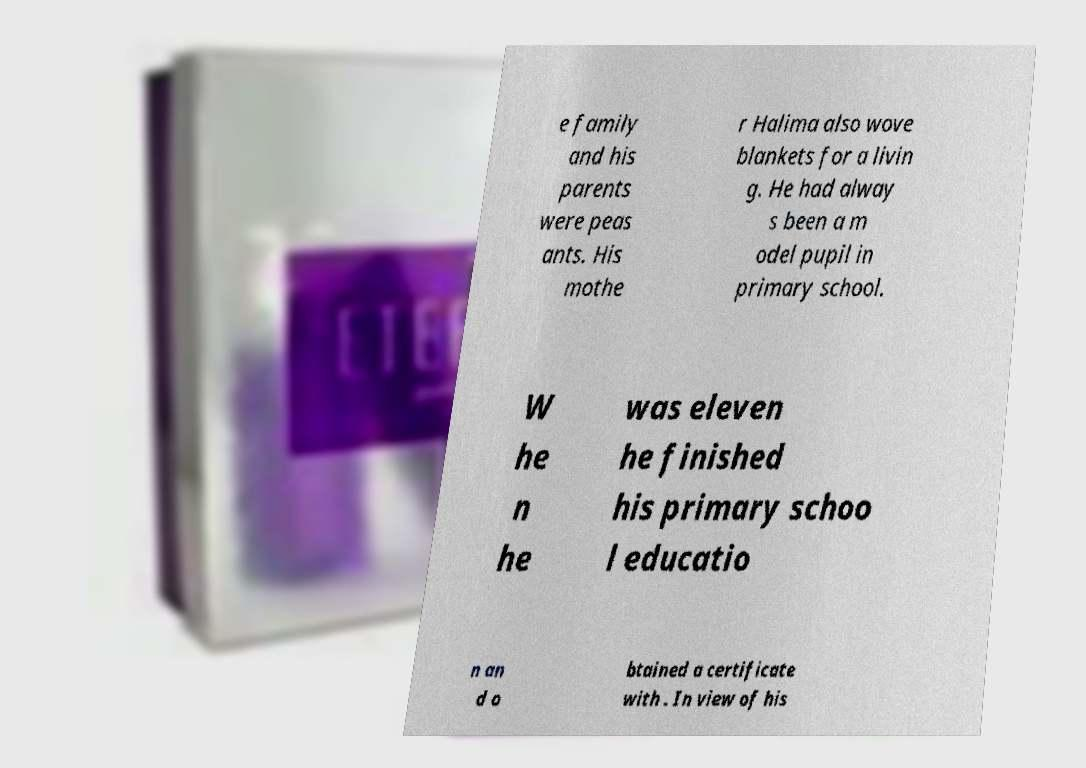Can you accurately transcribe the text from the provided image for me? e family and his parents were peas ants. His mothe r Halima also wove blankets for a livin g. He had alway s been a m odel pupil in primary school. W he n he was eleven he finished his primary schoo l educatio n an d o btained a certificate with . In view of his 